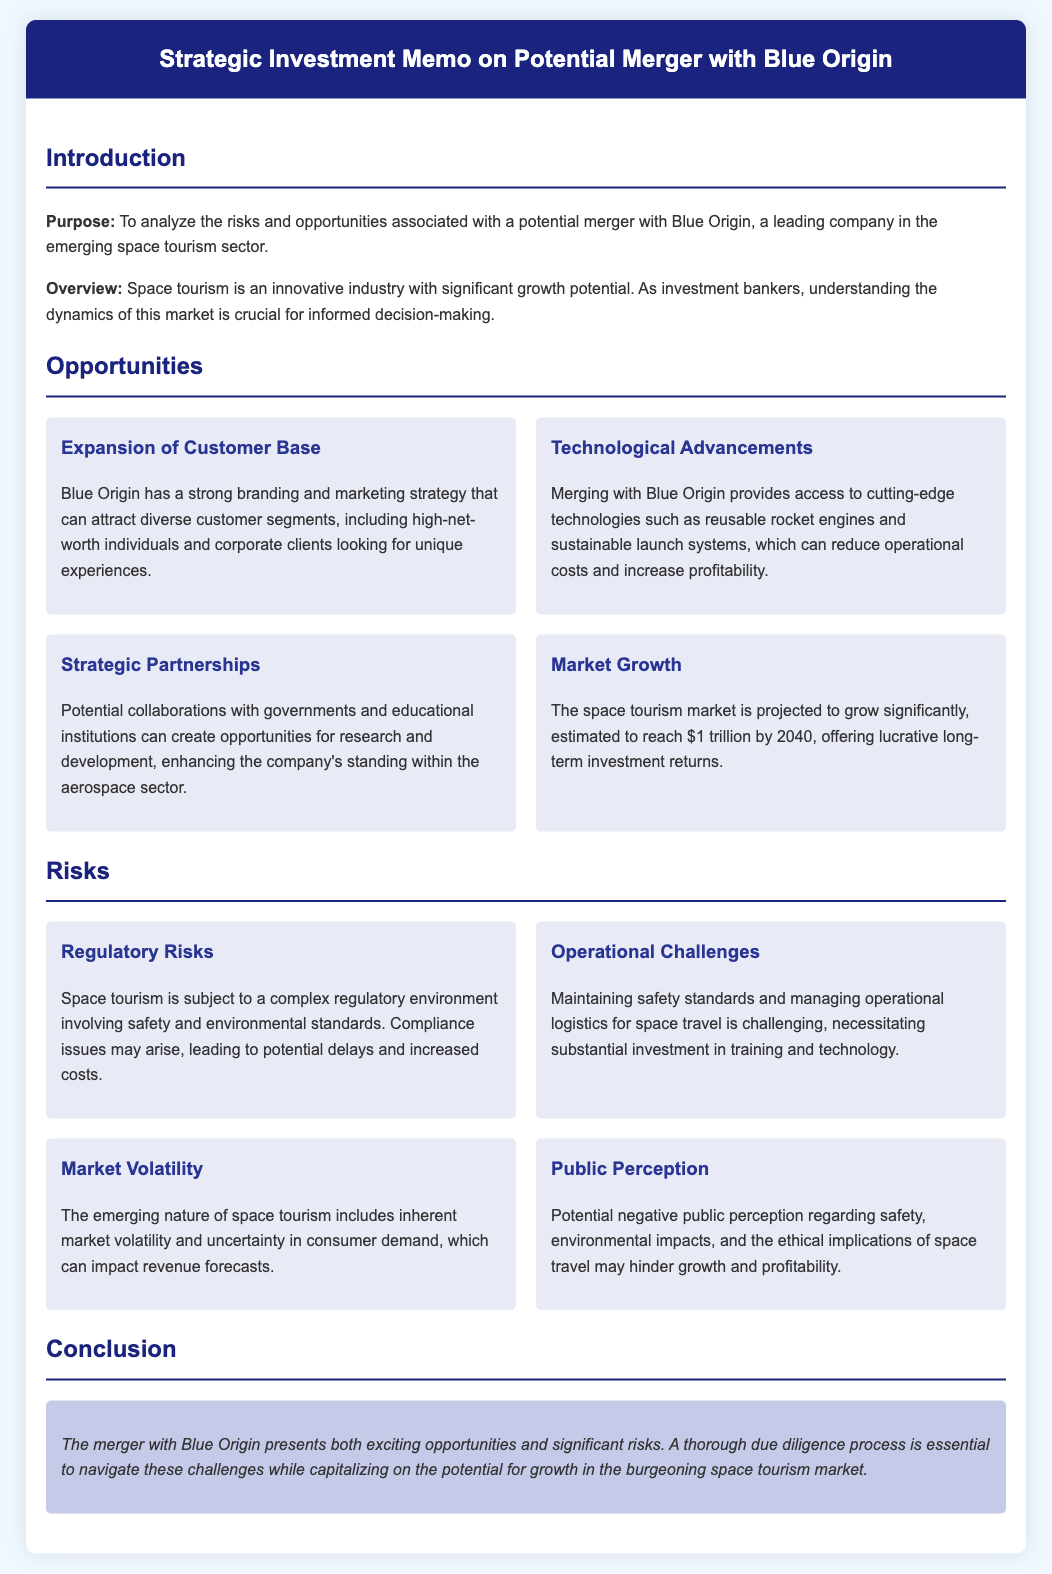What is the purpose of the memo? The purpose is to analyze the risks and opportunities associated with a potential merger with Blue Origin.
Answer: To analyze the risks and opportunities What is projected to be the space tourism market value by 2040? The document states that the market is estimated to reach $1 trillion by 2040.
Answer: $1 trillion What are potential collaborations mentioned in the memo? The memo mentions collaborations with governments and educational institutions for research and development.
Answer: Governments and educational institutions What kind of risks are related to regulatory issues? The document points out that space tourism involves a complex regulatory environment leading to compliance issues.
Answer: Compliance issues What does maintaining safety standards entail? Maintaining safety standards requires substantial investment in training and technology.
Answer: Substantial investment in training and technology What industry is Blue Origin a leader in? The document specifies that Blue Origin is a leading company in the emerging space tourism sector.
Answer: Space tourism What is an opportunity presented by merging with Blue Origin? Access to cutting-edge technologies such as reusable rocket engines is one opportunity.
Answer: Access to cutting-edge technologies What are operational challenges mentioned in the memo? The memo highlights the need to manage operational logistics for space travel.
Answer: Managing operational logistics What final recommendation does the memo provide? The memo concludes that a thorough due diligence process is essential for capitalizing on growth potential.
Answer: Thorough due diligence process 